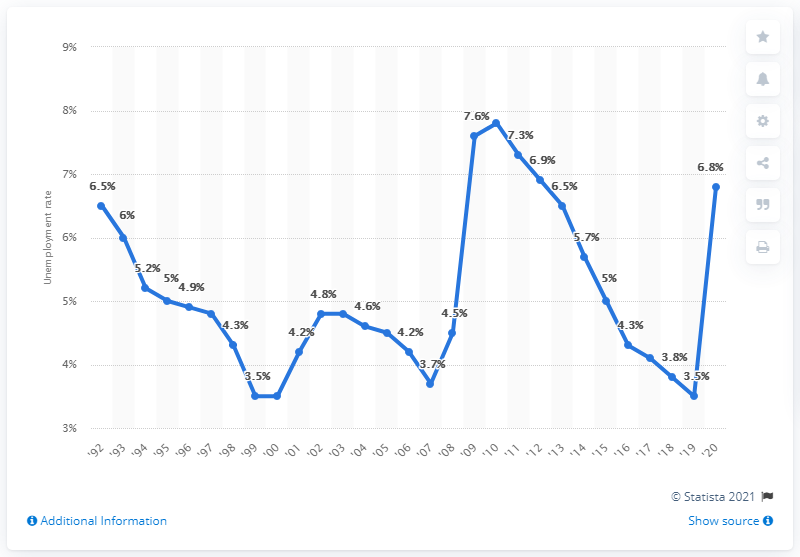Highlight a few significant elements in this photo. In 2020, the unemployment rate in Maryland was 6.8%. 